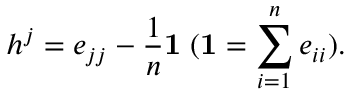<formula> <loc_0><loc_0><loc_500><loc_500>h ^ { j } = e _ { j j } - \frac { 1 } { n } { 1 } \, ( { 1 } = \sum _ { i = 1 } ^ { n } e _ { i i } ) .</formula> 